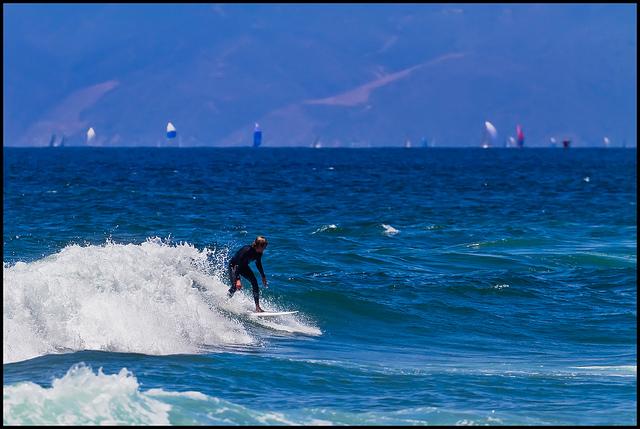How many surfer are in the water?
Answer briefly. 1. What are the white things in the sky?
Write a very short answer. Clouds. What is this person riding?
Concise answer only. Surfboard. What activity are the men participating in?
Concise answer only. Surfing. What is the person wearing?
Give a very brief answer. Wetsuit. Is the person probably wet?
Give a very brief answer. Yes. How high is the wave?
Give a very brief answer. Low. 